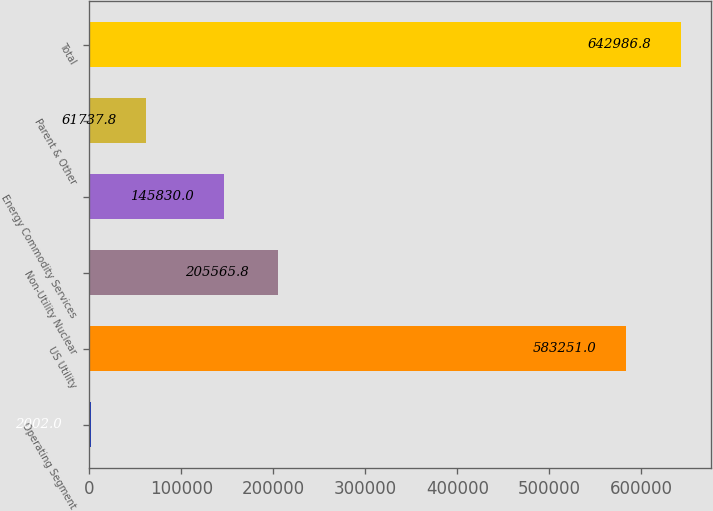<chart> <loc_0><loc_0><loc_500><loc_500><bar_chart><fcel>Operating Segment<fcel>US Utility<fcel>Non-Utility Nuclear<fcel>Energy Commodity Services<fcel>Parent & Other<fcel>Total<nl><fcel>2002<fcel>583251<fcel>205566<fcel>145830<fcel>61737.8<fcel>642987<nl></chart> 